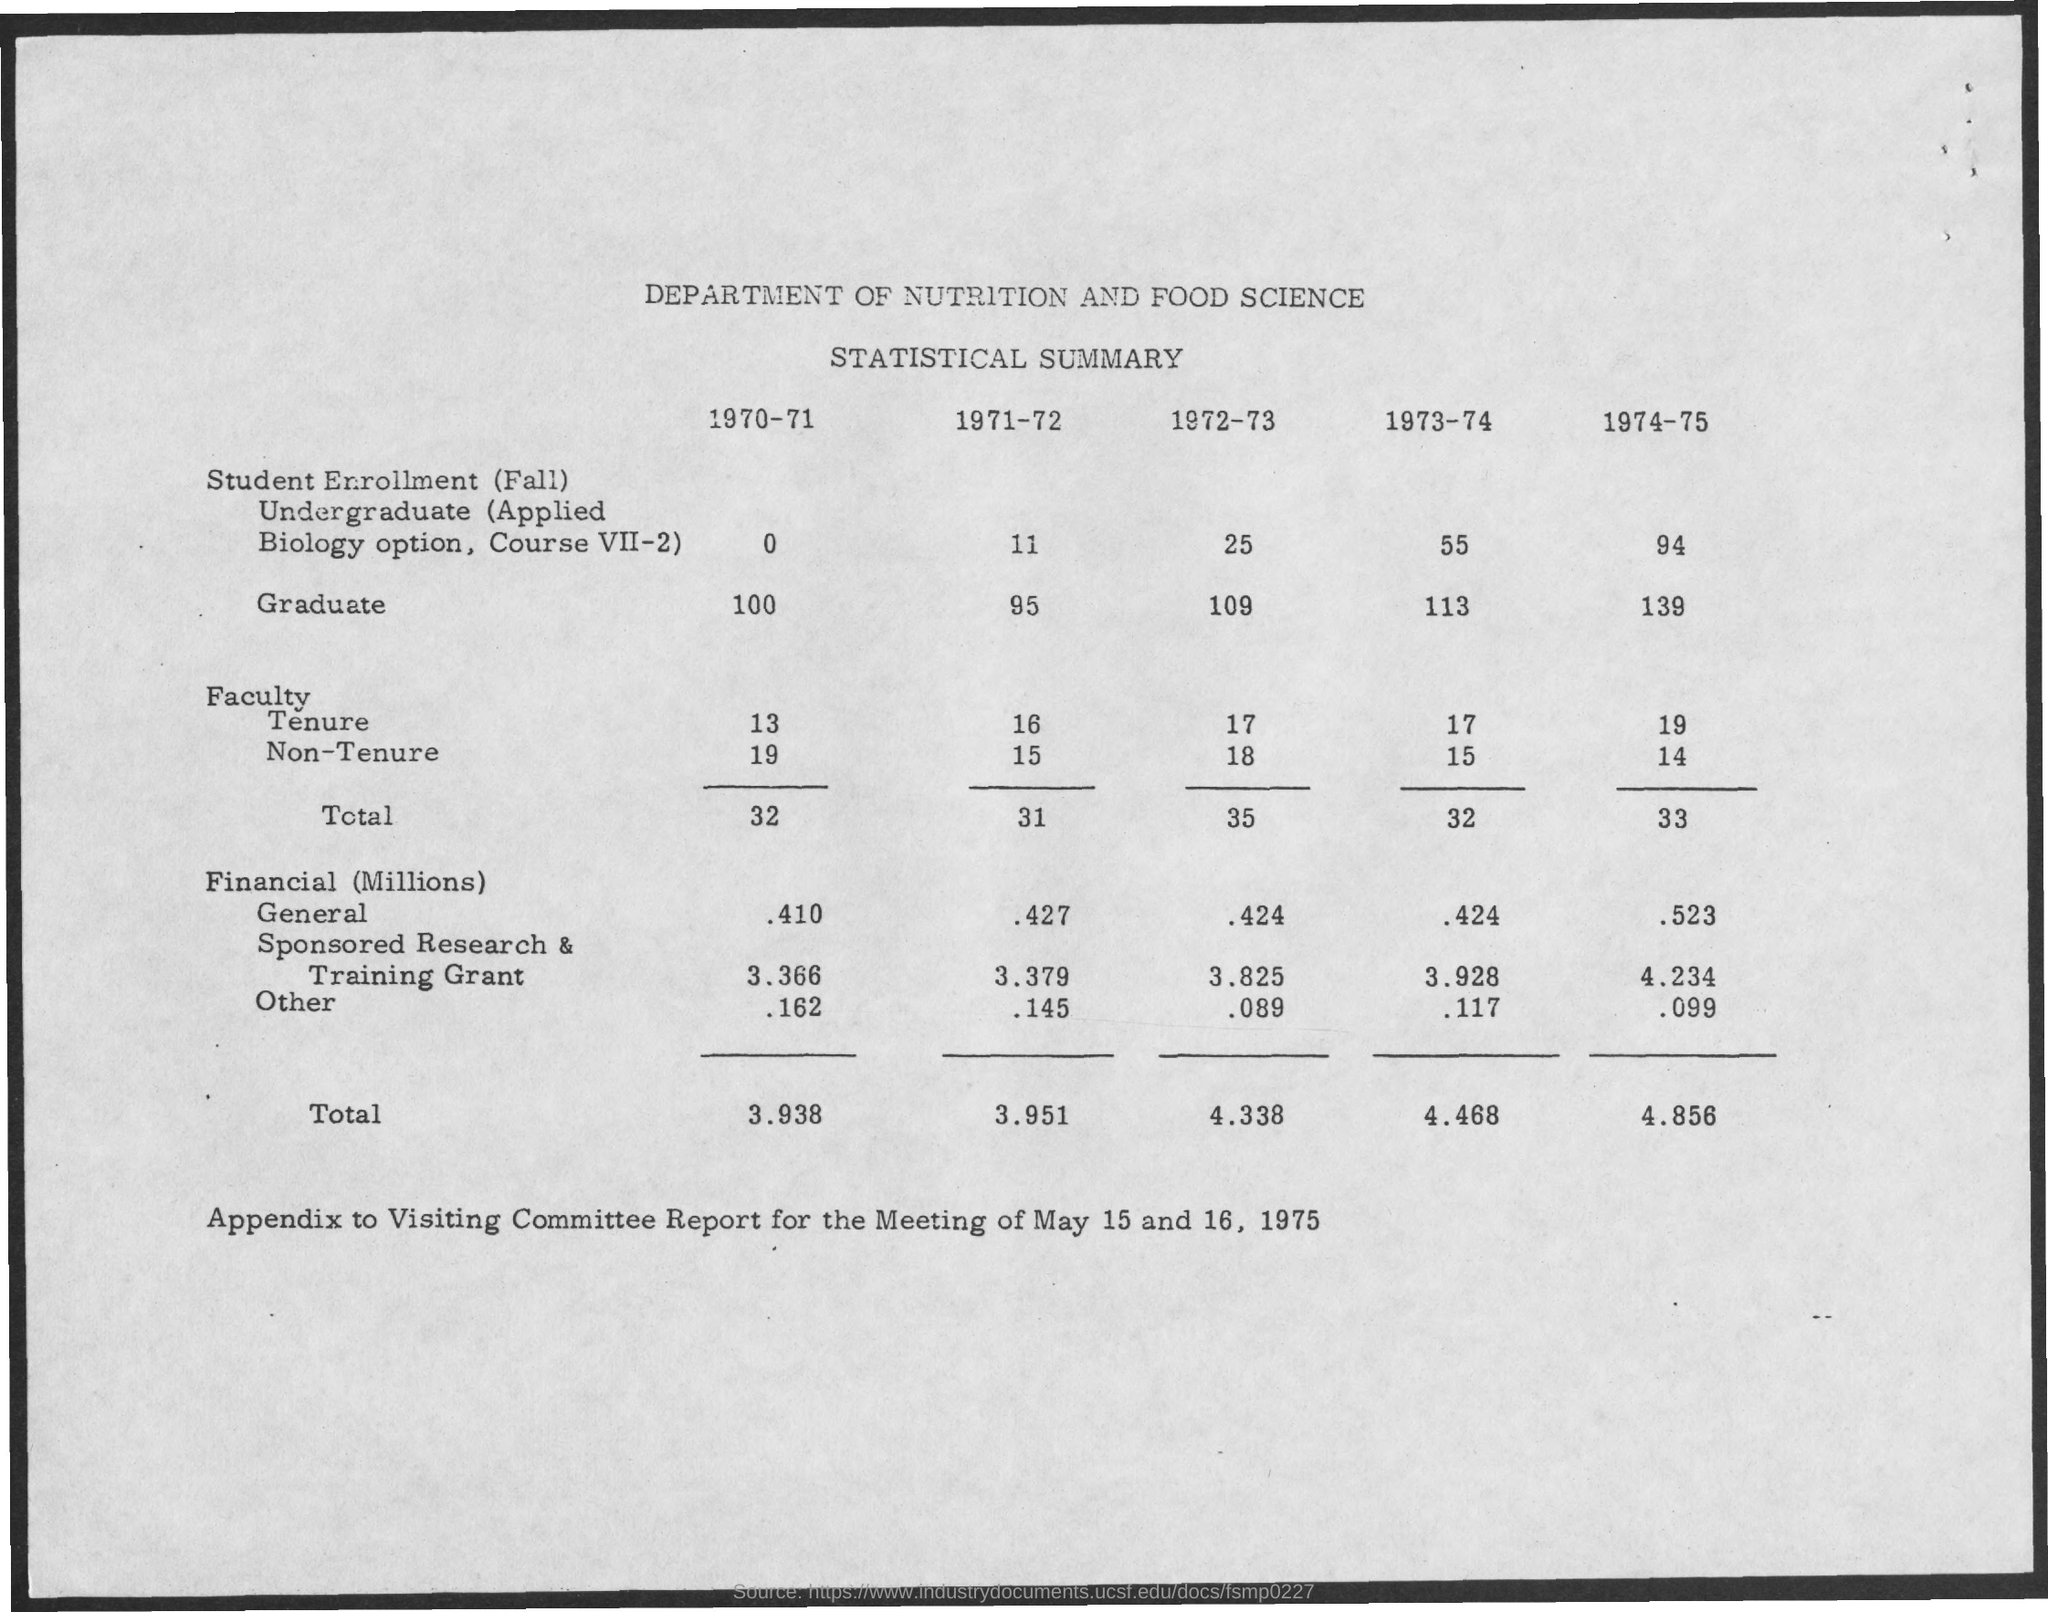Which department is it?
Give a very brief answer. Department of nutrition and food science. What type of data is it?
Make the answer very short. Statistical summary. How much is the financial total for 1970-71?
Ensure brevity in your answer.  3.938. How much is the faculty total for 1972-73?
Keep it short and to the point. 35. 